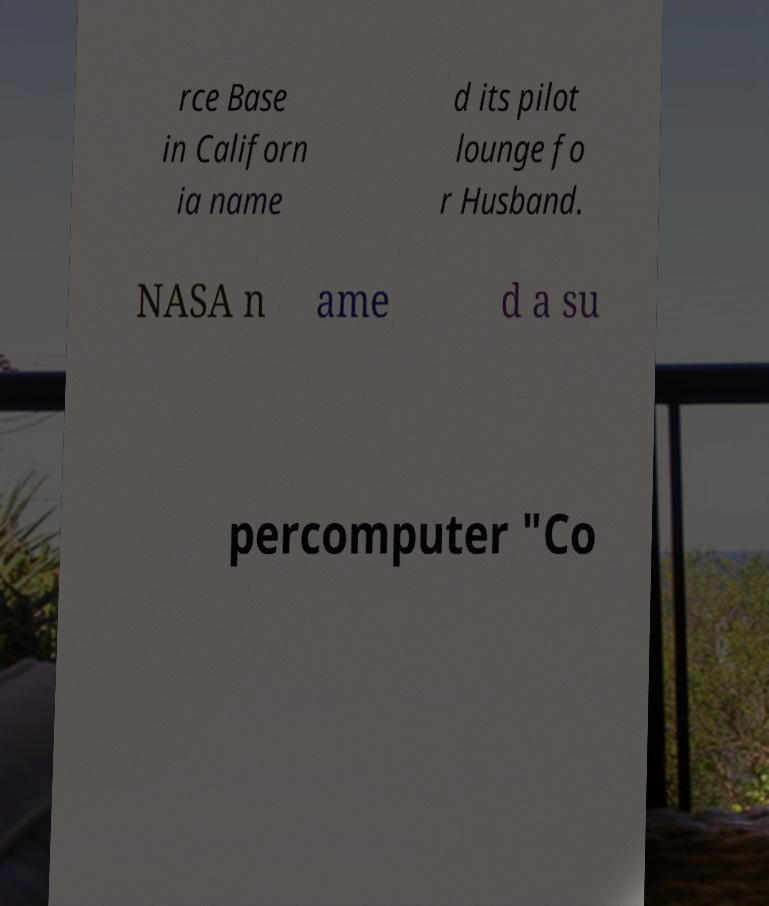Please read and relay the text visible in this image. What does it say? rce Base in Californ ia name d its pilot lounge fo r Husband. NASA n ame d a su percomputer "Co 